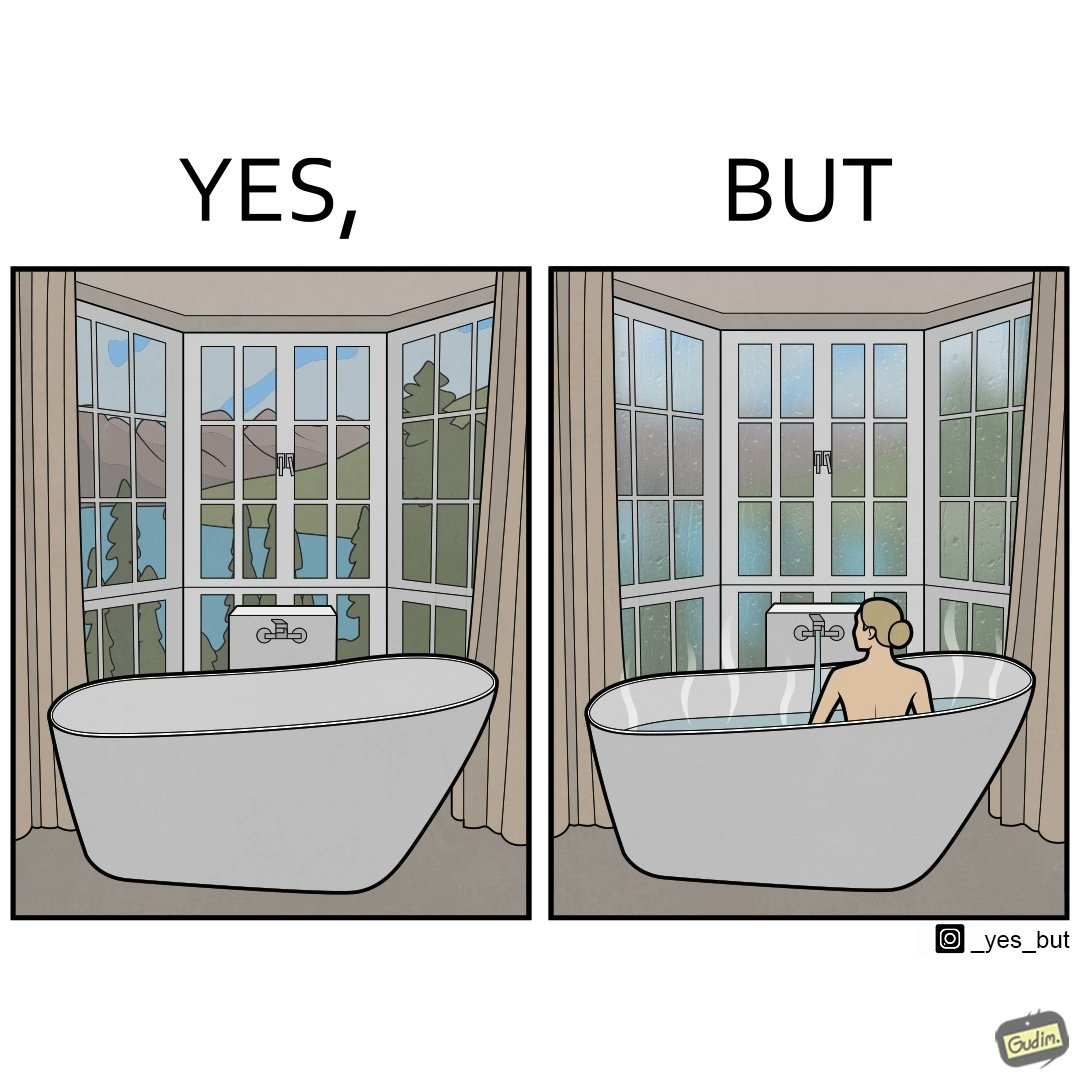Explain why this image is satirical. The image is ironical, as a bathtub near a window having a very scenic view, becomes misty when someone is bathing, thus making the scenic view blurry. 